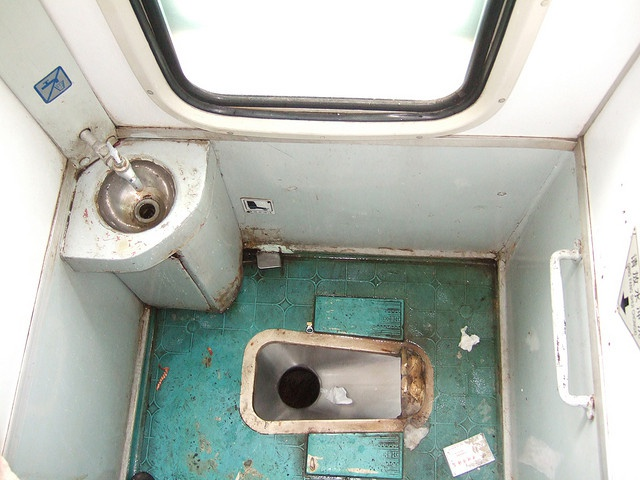Describe the objects in this image and their specific colors. I can see toilet in lightgray, gray, darkgray, teal, and tan tones and sink in lightgray, darkgray, and gray tones in this image. 